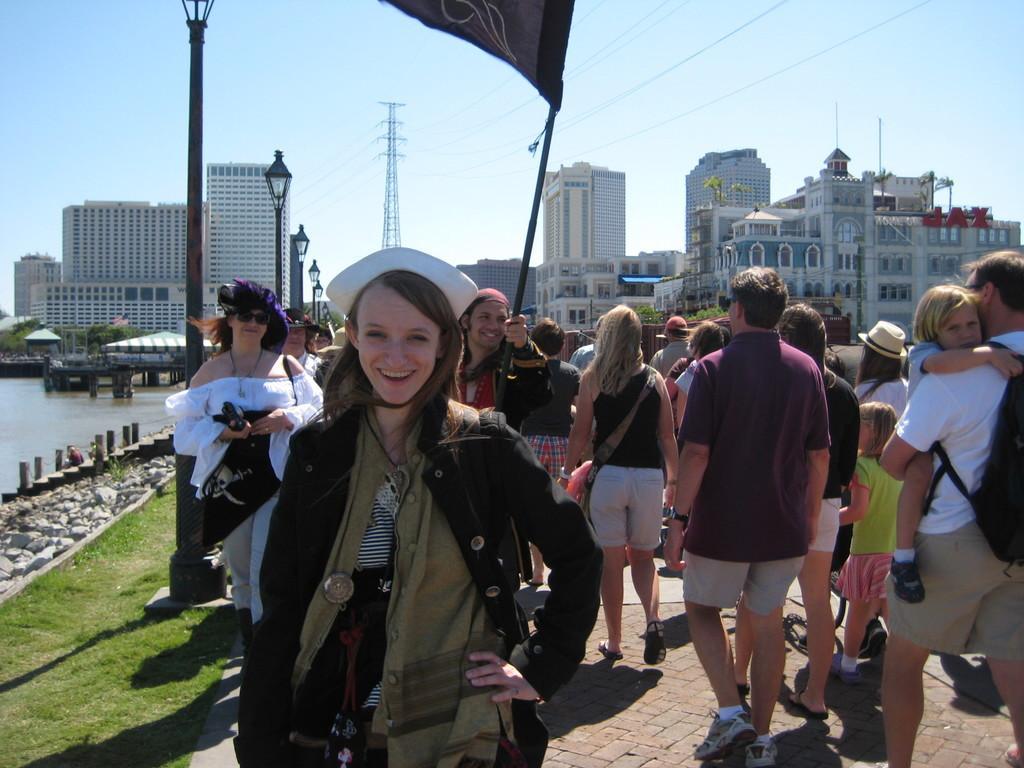Please provide a concise description of this image. This is the woman standing and smiling. There are group of people walking. This looks like a flag, which is hanging to the pole. These are the buildings. There is a current pole. I think these are the stairs. This looks like a water. I can see the trees. Here is the grass. These are the rocks. 